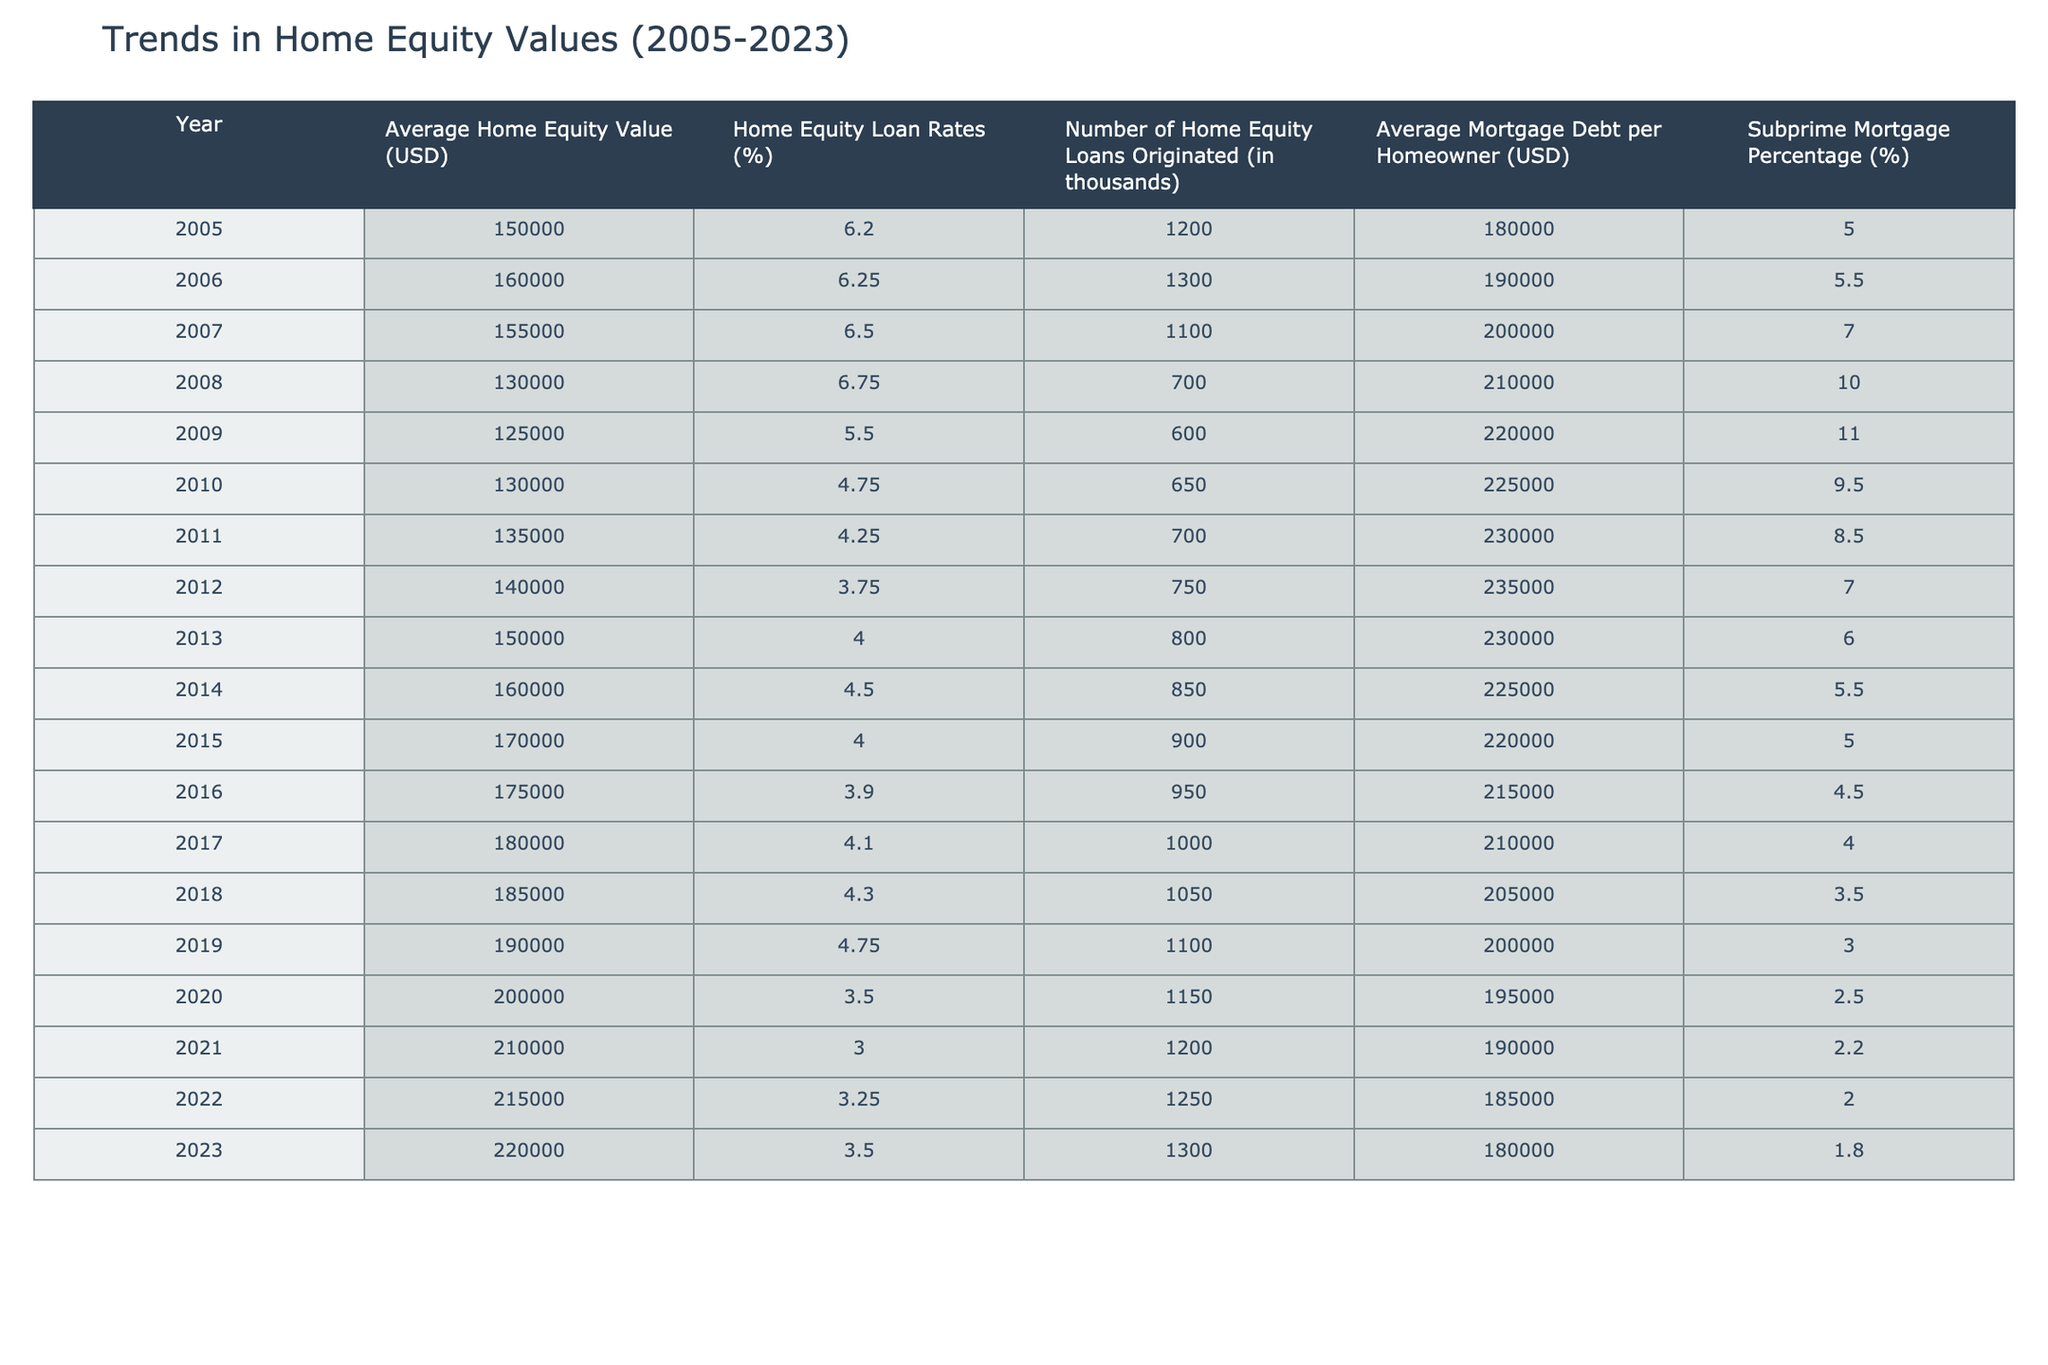What was the average home equity value in 2008? The average home equity value for the year 2008 is directly listed in the table under "Average Home Equity Value." Looking at that row, I find that the average home equity value in 2008 is 130,000 USD.
Answer: 130000 Which year had the highest home equity loan rates? To find the highest home equity loan rates, I’ll compare the "Home Equity Loan Rates (%)" column across all years. Upon reviewing, 2008 has the highest rate at 6.75%.
Answer: 2008 What was the trend in the number of home equity loans originated from 2008 to 2023? Analyzing the "Number of Home Equity Loans Originated (in thousands)" column from 2008 to 2023, I can see a gradual increase. In 2008, the number was 700 thousand, and by 2023 it increased to 1,300 thousand. This shows an upward trend.
Answer: Increase What is the difference between the average mortgage debt per homeowner in 2005 and 2023? I need to find the average mortgage debt per homeowner in the years 2005 and 2023 from the "Average Mortgage Debt per Homeowner (USD)" column. In 2005, it was 180,000 USD, and in 2023, it was 180,000 USD. The difference is 180,000 - 180,000 = 0.
Answer: 0 Was the subprime mortgage percentage greater than 7% in any year from 2005 to 2023? By looking at the "Subprime Mortgage Percentage (%)" column, I can see that the highest percentage was 11% in 2009 and that values greater than 7% appear in 2008 (10%) and 2009 (11%). Therefore, yes, there were years with percentages greater than 7%.
Answer: Yes What was the average home equity value from 2010 to 2015? I will add the average home equity values for the years 2010 (130,000), 2011 (135,000), 2012 (140,000), 2013 (150,000), 2014 (160,000), and 2015 (170,000). The total is 1,005,000. Dividing that by 6 (the number of years) gives an average of 167,500.
Answer: 167500 In which year did the average home equity value first exceed 200,000 USD? Observing the "Average Home Equity Value (USD)" column, I will look for the first occurrence that exceeds 200,000. This happens in 2020, where the value is 200,000 USD.
Answer: 2020 How many home equity loans were originated in total from 2005 to 2023? Summing the "Number of Home Equity Loans Originated (in thousands)" values from each year (1200 + 1300 + 1100 + 700 + 600 + 650 + 700 + 750 + 800 + 850 + 900 + 950 + 1000 + 1050 + 1100 + 1150 + 1200 + 1250 + 1300) gives a total of 17,800 thousand loans originated.
Answer: 17800 What percentage of mortgages were subprime in 2012? The "Subprime Mortgage Percentage (%)" column shows 2012 had a subprime percentage of 7.0%. This is the direct answer without additional calculations needed.
Answer: 7.0 